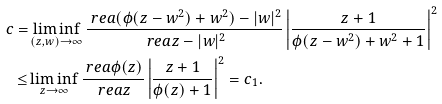<formula> <loc_0><loc_0><loc_500><loc_500>c = & \liminf _ { ( z , w ) \to \infty } \frac { \ r e a ( \phi ( z - w ^ { 2 } ) + w ^ { 2 } ) - | w | ^ { 2 } } { \ r e a z - | w | ^ { 2 } } \left | \frac { z + 1 } { \phi ( z - w ^ { 2 } ) + w ^ { 2 } + 1 } \right | ^ { 2 } \\ \leq & \liminf _ { z \to \infty } \frac { \ r e a \phi ( z ) } { \ r e a z } \left | \frac { z + 1 } { \phi ( z ) + 1 } \right | ^ { 2 } = c _ { 1 } .</formula> 